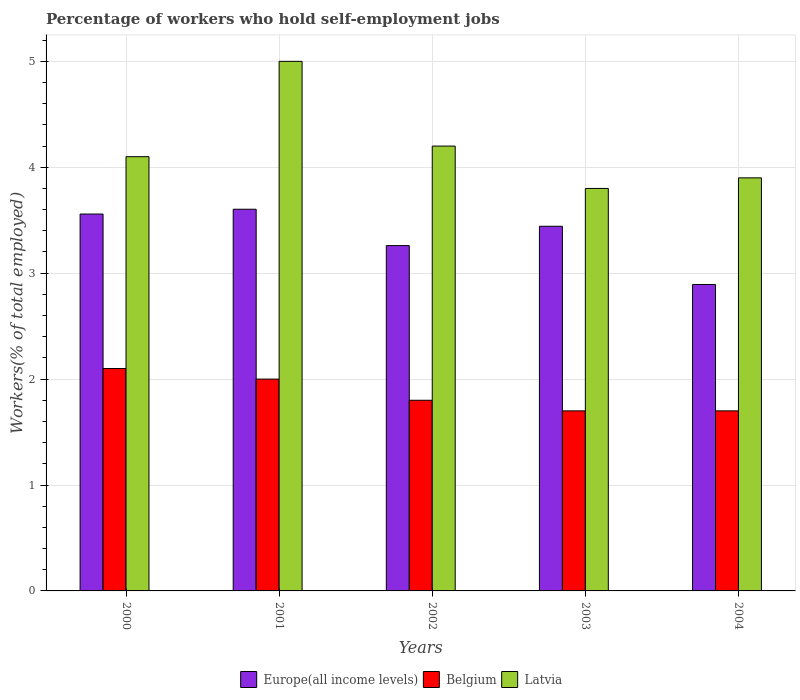How many different coloured bars are there?
Offer a very short reply. 3. How many groups of bars are there?
Make the answer very short. 5. Are the number of bars per tick equal to the number of legend labels?
Offer a very short reply. Yes. How many bars are there on the 5th tick from the left?
Your answer should be very brief. 3. In how many cases, is the number of bars for a given year not equal to the number of legend labels?
Offer a terse response. 0. What is the percentage of self-employed workers in Belgium in 2003?
Make the answer very short. 1.7. Across all years, what is the minimum percentage of self-employed workers in Europe(all income levels)?
Offer a terse response. 2.89. In which year was the percentage of self-employed workers in Belgium maximum?
Keep it short and to the point. 2000. In which year was the percentage of self-employed workers in Latvia minimum?
Keep it short and to the point. 2003. What is the total percentage of self-employed workers in Belgium in the graph?
Provide a succinct answer. 9.3. What is the difference between the percentage of self-employed workers in Belgium in 2002 and that in 2003?
Your answer should be compact. 0.1. What is the difference between the percentage of self-employed workers in Belgium in 2003 and the percentage of self-employed workers in Europe(all income levels) in 2004?
Provide a succinct answer. -1.19. What is the average percentage of self-employed workers in Europe(all income levels) per year?
Offer a very short reply. 3.35. In the year 2000, what is the difference between the percentage of self-employed workers in Europe(all income levels) and percentage of self-employed workers in Latvia?
Ensure brevity in your answer.  -0.54. In how many years, is the percentage of self-employed workers in Belgium greater than 0.2 %?
Your answer should be very brief. 5. What is the ratio of the percentage of self-employed workers in Latvia in 2001 to that in 2002?
Offer a very short reply. 1.19. Is the difference between the percentage of self-employed workers in Europe(all income levels) in 2001 and 2003 greater than the difference between the percentage of self-employed workers in Latvia in 2001 and 2003?
Your answer should be compact. No. What is the difference between the highest and the second highest percentage of self-employed workers in Belgium?
Ensure brevity in your answer.  0.1. What is the difference between the highest and the lowest percentage of self-employed workers in Latvia?
Your answer should be compact. 1.2. In how many years, is the percentage of self-employed workers in Europe(all income levels) greater than the average percentage of self-employed workers in Europe(all income levels) taken over all years?
Make the answer very short. 3. Is the sum of the percentage of self-employed workers in Latvia in 2000 and 2001 greater than the maximum percentage of self-employed workers in Europe(all income levels) across all years?
Keep it short and to the point. Yes. What does the 3rd bar from the right in 2001 represents?
Keep it short and to the point. Europe(all income levels). Is it the case that in every year, the sum of the percentage of self-employed workers in Belgium and percentage of self-employed workers in Latvia is greater than the percentage of self-employed workers in Europe(all income levels)?
Your answer should be compact. Yes. How many bars are there?
Offer a very short reply. 15. How many years are there in the graph?
Your answer should be compact. 5. What is the difference between two consecutive major ticks on the Y-axis?
Keep it short and to the point. 1. Does the graph contain grids?
Keep it short and to the point. Yes. Where does the legend appear in the graph?
Offer a very short reply. Bottom center. How are the legend labels stacked?
Make the answer very short. Horizontal. What is the title of the graph?
Give a very brief answer. Percentage of workers who hold self-employment jobs. What is the label or title of the X-axis?
Give a very brief answer. Years. What is the label or title of the Y-axis?
Keep it short and to the point. Workers(% of total employed). What is the Workers(% of total employed) of Europe(all income levels) in 2000?
Provide a short and direct response. 3.56. What is the Workers(% of total employed) of Belgium in 2000?
Give a very brief answer. 2.1. What is the Workers(% of total employed) of Latvia in 2000?
Provide a short and direct response. 4.1. What is the Workers(% of total employed) in Europe(all income levels) in 2001?
Make the answer very short. 3.6. What is the Workers(% of total employed) in Belgium in 2001?
Ensure brevity in your answer.  2. What is the Workers(% of total employed) of Europe(all income levels) in 2002?
Make the answer very short. 3.26. What is the Workers(% of total employed) in Belgium in 2002?
Offer a very short reply. 1.8. What is the Workers(% of total employed) in Latvia in 2002?
Offer a terse response. 4.2. What is the Workers(% of total employed) in Europe(all income levels) in 2003?
Your answer should be compact. 3.44. What is the Workers(% of total employed) of Belgium in 2003?
Keep it short and to the point. 1.7. What is the Workers(% of total employed) in Latvia in 2003?
Your response must be concise. 3.8. What is the Workers(% of total employed) of Europe(all income levels) in 2004?
Offer a terse response. 2.89. What is the Workers(% of total employed) of Belgium in 2004?
Your response must be concise. 1.7. What is the Workers(% of total employed) of Latvia in 2004?
Ensure brevity in your answer.  3.9. Across all years, what is the maximum Workers(% of total employed) of Europe(all income levels)?
Offer a terse response. 3.6. Across all years, what is the maximum Workers(% of total employed) in Belgium?
Provide a short and direct response. 2.1. Across all years, what is the maximum Workers(% of total employed) in Latvia?
Provide a short and direct response. 5. Across all years, what is the minimum Workers(% of total employed) in Europe(all income levels)?
Provide a succinct answer. 2.89. Across all years, what is the minimum Workers(% of total employed) in Belgium?
Make the answer very short. 1.7. Across all years, what is the minimum Workers(% of total employed) of Latvia?
Ensure brevity in your answer.  3.8. What is the total Workers(% of total employed) in Europe(all income levels) in the graph?
Provide a succinct answer. 16.76. What is the total Workers(% of total employed) in Belgium in the graph?
Provide a short and direct response. 9.3. What is the total Workers(% of total employed) in Latvia in the graph?
Offer a very short reply. 21. What is the difference between the Workers(% of total employed) in Europe(all income levels) in 2000 and that in 2001?
Offer a terse response. -0.05. What is the difference between the Workers(% of total employed) in Latvia in 2000 and that in 2001?
Make the answer very short. -0.9. What is the difference between the Workers(% of total employed) of Europe(all income levels) in 2000 and that in 2002?
Offer a very short reply. 0.3. What is the difference between the Workers(% of total employed) in Belgium in 2000 and that in 2002?
Your response must be concise. 0.3. What is the difference between the Workers(% of total employed) of Latvia in 2000 and that in 2002?
Offer a terse response. -0.1. What is the difference between the Workers(% of total employed) of Europe(all income levels) in 2000 and that in 2003?
Provide a succinct answer. 0.12. What is the difference between the Workers(% of total employed) in Europe(all income levels) in 2000 and that in 2004?
Your answer should be compact. 0.66. What is the difference between the Workers(% of total employed) of Latvia in 2000 and that in 2004?
Keep it short and to the point. 0.2. What is the difference between the Workers(% of total employed) in Europe(all income levels) in 2001 and that in 2002?
Your answer should be very brief. 0.34. What is the difference between the Workers(% of total employed) of Latvia in 2001 and that in 2002?
Give a very brief answer. 0.8. What is the difference between the Workers(% of total employed) of Europe(all income levels) in 2001 and that in 2003?
Offer a very short reply. 0.16. What is the difference between the Workers(% of total employed) in Belgium in 2001 and that in 2003?
Your answer should be compact. 0.3. What is the difference between the Workers(% of total employed) in Europe(all income levels) in 2001 and that in 2004?
Your answer should be compact. 0.71. What is the difference between the Workers(% of total employed) in Europe(all income levels) in 2002 and that in 2003?
Provide a succinct answer. -0.18. What is the difference between the Workers(% of total employed) of Latvia in 2002 and that in 2003?
Offer a terse response. 0.4. What is the difference between the Workers(% of total employed) of Europe(all income levels) in 2002 and that in 2004?
Make the answer very short. 0.37. What is the difference between the Workers(% of total employed) in Europe(all income levels) in 2003 and that in 2004?
Offer a very short reply. 0.55. What is the difference between the Workers(% of total employed) of Europe(all income levels) in 2000 and the Workers(% of total employed) of Belgium in 2001?
Your response must be concise. 1.56. What is the difference between the Workers(% of total employed) of Europe(all income levels) in 2000 and the Workers(% of total employed) of Latvia in 2001?
Offer a terse response. -1.44. What is the difference between the Workers(% of total employed) in Europe(all income levels) in 2000 and the Workers(% of total employed) in Belgium in 2002?
Your answer should be very brief. 1.76. What is the difference between the Workers(% of total employed) in Europe(all income levels) in 2000 and the Workers(% of total employed) in Latvia in 2002?
Provide a short and direct response. -0.64. What is the difference between the Workers(% of total employed) of Europe(all income levels) in 2000 and the Workers(% of total employed) of Belgium in 2003?
Make the answer very short. 1.86. What is the difference between the Workers(% of total employed) of Europe(all income levels) in 2000 and the Workers(% of total employed) of Latvia in 2003?
Make the answer very short. -0.24. What is the difference between the Workers(% of total employed) in Belgium in 2000 and the Workers(% of total employed) in Latvia in 2003?
Offer a very short reply. -1.7. What is the difference between the Workers(% of total employed) in Europe(all income levels) in 2000 and the Workers(% of total employed) in Belgium in 2004?
Make the answer very short. 1.86. What is the difference between the Workers(% of total employed) of Europe(all income levels) in 2000 and the Workers(% of total employed) of Latvia in 2004?
Offer a very short reply. -0.34. What is the difference between the Workers(% of total employed) in Europe(all income levels) in 2001 and the Workers(% of total employed) in Belgium in 2002?
Provide a short and direct response. 1.8. What is the difference between the Workers(% of total employed) of Europe(all income levels) in 2001 and the Workers(% of total employed) of Latvia in 2002?
Your answer should be compact. -0.6. What is the difference between the Workers(% of total employed) of Europe(all income levels) in 2001 and the Workers(% of total employed) of Belgium in 2003?
Offer a terse response. 1.9. What is the difference between the Workers(% of total employed) in Europe(all income levels) in 2001 and the Workers(% of total employed) in Latvia in 2003?
Offer a terse response. -0.2. What is the difference between the Workers(% of total employed) in Europe(all income levels) in 2001 and the Workers(% of total employed) in Belgium in 2004?
Your response must be concise. 1.9. What is the difference between the Workers(% of total employed) of Europe(all income levels) in 2001 and the Workers(% of total employed) of Latvia in 2004?
Offer a terse response. -0.3. What is the difference between the Workers(% of total employed) of Europe(all income levels) in 2002 and the Workers(% of total employed) of Belgium in 2003?
Offer a very short reply. 1.56. What is the difference between the Workers(% of total employed) in Europe(all income levels) in 2002 and the Workers(% of total employed) in Latvia in 2003?
Ensure brevity in your answer.  -0.54. What is the difference between the Workers(% of total employed) in Belgium in 2002 and the Workers(% of total employed) in Latvia in 2003?
Your answer should be compact. -2. What is the difference between the Workers(% of total employed) of Europe(all income levels) in 2002 and the Workers(% of total employed) of Belgium in 2004?
Provide a short and direct response. 1.56. What is the difference between the Workers(% of total employed) in Europe(all income levels) in 2002 and the Workers(% of total employed) in Latvia in 2004?
Offer a very short reply. -0.64. What is the difference between the Workers(% of total employed) of Belgium in 2002 and the Workers(% of total employed) of Latvia in 2004?
Give a very brief answer. -2.1. What is the difference between the Workers(% of total employed) in Europe(all income levels) in 2003 and the Workers(% of total employed) in Belgium in 2004?
Your answer should be compact. 1.74. What is the difference between the Workers(% of total employed) of Europe(all income levels) in 2003 and the Workers(% of total employed) of Latvia in 2004?
Your response must be concise. -0.46. What is the average Workers(% of total employed) of Europe(all income levels) per year?
Your answer should be compact. 3.35. What is the average Workers(% of total employed) in Belgium per year?
Provide a short and direct response. 1.86. In the year 2000, what is the difference between the Workers(% of total employed) in Europe(all income levels) and Workers(% of total employed) in Belgium?
Offer a terse response. 1.46. In the year 2000, what is the difference between the Workers(% of total employed) in Europe(all income levels) and Workers(% of total employed) in Latvia?
Offer a very short reply. -0.54. In the year 2001, what is the difference between the Workers(% of total employed) in Europe(all income levels) and Workers(% of total employed) in Belgium?
Your response must be concise. 1.6. In the year 2001, what is the difference between the Workers(% of total employed) in Europe(all income levels) and Workers(% of total employed) in Latvia?
Your response must be concise. -1.4. In the year 2001, what is the difference between the Workers(% of total employed) of Belgium and Workers(% of total employed) of Latvia?
Your answer should be very brief. -3. In the year 2002, what is the difference between the Workers(% of total employed) of Europe(all income levels) and Workers(% of total employed) of Belgium?
Keep it short and to the point. 1.46. In the year 2002, what is the difference between the Workers(% of total employed) in Europe(all income levels) and Workers(% of total employed) in Latvia?
Offer a very short reply. -0.94. In the year 2002, what is the difference between the Workers(% of total employed) in Belgium and Workers(% of total employed) in Latvia?
Offer a very short reply. -2.4. In the year 2003, what is the difference between the Workers(% of total employed) in Europe(all income levels) and Workers(% of total employed) in Belgium?
Make the answer very short. 1.74. In the year 2003, what is the difference between the Workers(% of total employed) in Europe(all income levels) and Workers(% of total employed) in Latvia?
Provide a succinct answer. -0.36. In the year 2003, what is the difference between the Workers(% of total employed) in Belgium and Workers(% of total employed) in Latvia?
Provide a succinct answer. -2.1. In the year 2004, what is the difference between the Workers(% of total employed) in Europe(all income levels) and Workers(% of total employed) in Belgium?
Make the answer very short. 1.19. In the year 2004, what is the difference between the Workers(% of total employed) of Europe(all income levels) and Workers(% of total employed) of Latvia?
Ensure brevity in your answer.  -1.01. What is the ratio of the Workers(% of total employed) in Europe(all income levels) in 2000 to that in 2001?
Offer a very short reply. 0.99. What is the ratio of the Workers(% of total employed) of Latvia in 2000 to that in 2001?
Your answer should be very brief. 0.82. What is the ratio of the Workers(% of total employed) of Europe(all income levels) in 2000 to that in 2002?
Your response must be concise. 1.09. What is the ratio of the Workers(% of total employed) in Belgium in 2000 to that in 2002?
Give a very brief answer. 1.17. What is the ratio of the Workers(% of total employed) in Latvia in 2000 to that in 2002?
Your answer should be very brief. 0.98. What is the ratio of the Workers(% of total employed) in Europe(all income levels) in 2000 to that in 2003?
Your response must be concise. 1.03. What is the ratio of the Workers(% of total employed) in Belgium in 2000 to that in 2003?
Offer a very short reply. 1.24. What is the ratio of the Workers(% of total employed) in Latvia in 2000 to that in 2003?
Make the answer very short. 1.08. What is the ratio of the Workers(% of total employed) in Europe(all income levels) in 2000 to that in 2004?
Your answer should be compact. 1.23. What is the ratio of the Workers(% of total employed) of Belgium in 2000 to that in 2004?
Offer a very short reply. 1.24. What is the ratio of the Workers(% of total employed) of Latvia in 2000 to that in 2004?
Your answer should be very brief. 1.05. What is the ratio of the Workers(% of total employed) in Europe(all income levels) in 2001 to that in 2002?
Offer a very short reply. 1.11. What is the ratio of the Workers(% of total employed) in Belgium in 2001 to that in 2002?
Make the answer very short. 1.11. What is the ratio of the Workers(% of total employed) of Latvia in 2001 to that in 2002?
Ensure brevity in your answer.  1.19. What is the ratio of the Workers(% of total employed) of Europe(all income levels) in 2001 to that in 2003?
Offer a terse response. 1.05. What is the ratio of the Workers(% of total employed) of Belgium in 2001 to that in 2003?
Provide a succinct answer. 1.18. What is the ratio of the Workers(% of total employed) in Latvia in 2001 to that in 2003?
Provide a succinct answer. 1.32. What is the ratio of the Workers(% of total employed) in Europe(all income levels) in 2001 to that in 2004?
Give a very brief answer. 1.25. What is the ratio of the Workers(% of total employed) of Belgium in 2001 to that in 2004?
Offer a very short reply. 1.18. What is the ratio of the Workers(% of total employed) in Latvia in 2001 to that in 2004?
Your response must be concise. 1.28. What is the ratio of the Workers(% of total employed) in Europe(all income levels) in 2002 to that in 2003?
Offer a terse response. 0.95. What is the ratio of the Workers(% of total employed) in Belgium in 2002 to that in 2003?
Your answer should be compact. 1.06. What is the ratio of the Workers(% of total employed) in Latvia in 2002 to that in 2003?
Ensure brevity in your answer.  1.11. What is the ratio of the Workers(% of total employed) in Europe(all income levels) in 2002 to that in 2004?
Make the answer very short. 1.13. What is the ratio of the Workers(% of total employed) of Belgium in 2002 to that in 2004?
Ensure brevity in your answer.  1.06. What is the ratio of the Workers(% of total employed) in Latvia in 2002 to that in 2004?
Offer a terse response. 1.08. What is the ratio of the Workers(% of total employed) of Europe(all income levels) in 2003 to that in 2004?
Offer a terse response. 1.19. What is the ratio of the Workers(% of total employed) of Latvia in 2003 to that in 2004?
Your response must be concise. 0.97. What is the difference between the highest and the second highest Workers(% of total employed) in Europe(all income levels)?
Your response must be concise. 0.05. What is the difference between the highest and the second highest Workers(% of total employed) of Belgium?
Make the answer very short. 0.1. What is the difference between the highest and the lowest Workers(% of total employed) of Europe(all income levels)?
Your answer should be compact. 0.71. 